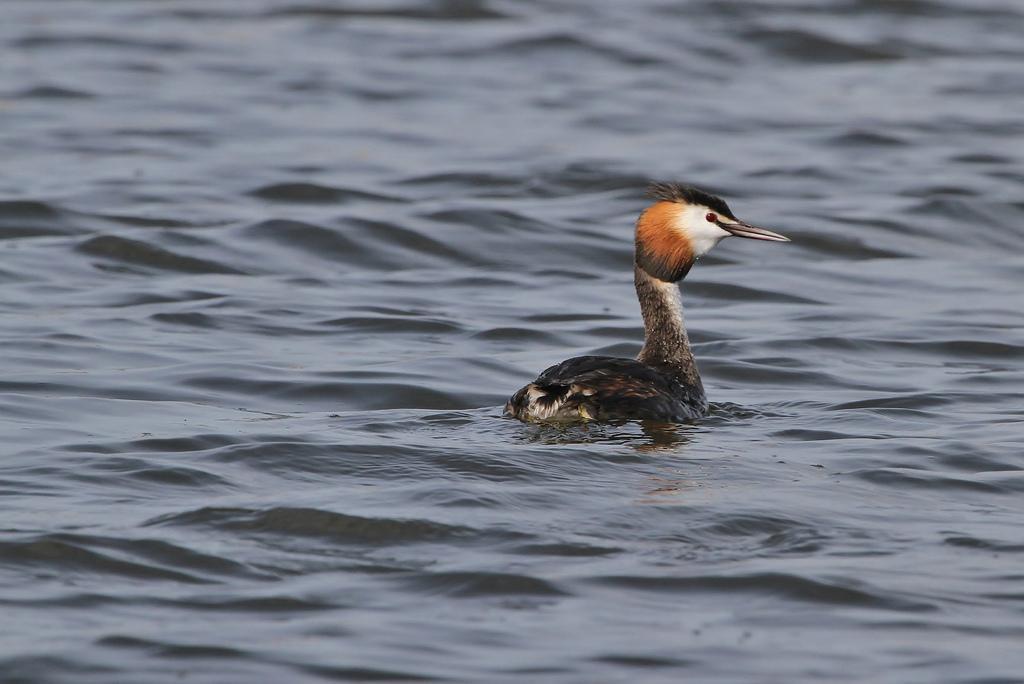Describe this image in one or two sentences. In the image in the center we can see one bird in the water,which is in black,orange and white color. 